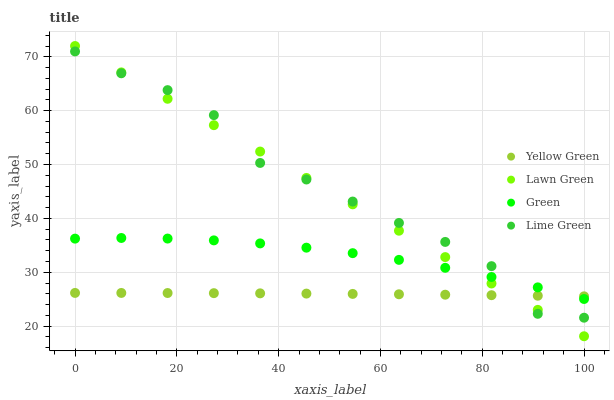Does Yellow Green have the minimum area under the curve?
Answer yes or no. Yes. Does Lime Green have the maximum area under the curve?
Answer yes or no. Yes. Does Green have the minimum area under the curve?
Answer yes or no. No. Does Green have the maximum area under the curve?
Answer yes or no. No. Is Lawn Green the smoothest?
Answer yes or no. Yes. Is Lime Green the roughest?
Answer yes or no. Yes. Is Green the smoothest?
Answer yes or no. No. Is Green the roughest?
Answer yes or no. No. Does Lawn Green have the lowest value?
Answer yes or no. Yes. Does Green have the lowest value?
Answer yes or no. No. Does Lawn Green have the highest value?
Answer yes or no. Yes. Does Green have the highest value?
Answer yes or no. No. Does Lawn Green intersect Green?
Answer yes or no. Yes. Is Lawn Green less than Green?
Answer yes or no. No. Is Lawn Green greater than Green?
Answer yes or no. No. 